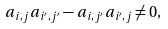Convert formula to latex. <formula><loc_0><loc_0><loc_500><loc_500>a _ { i , j } a _ { i ^ { \prime } , j ^ { \prime } } - a _ { i , j ^ { \prime } } a _ { i ^ { \prime } , j } \neq 0 ,</formula> 